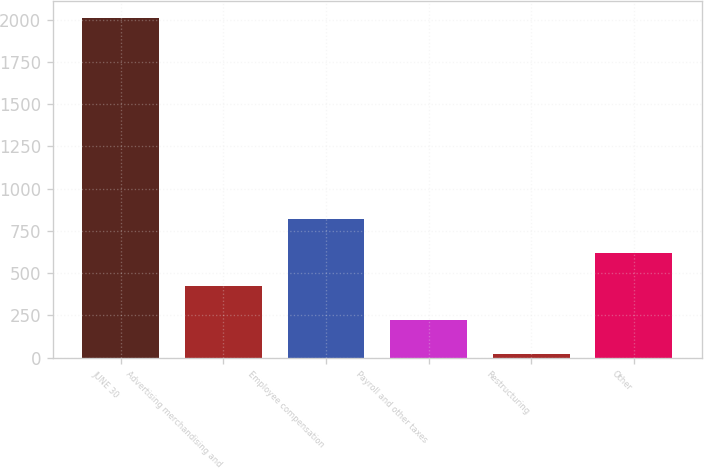Convert chart. <chart><loc_0><loc_0><loc_500><loc_500><bar_chart><fcel>JUNE 30<fcel>Advertising merchandising and<fcel>Employee compensation<fcel>Payroll and other taxes<fcel>Restructuring<fcel>Other<nl><fcel>2013<fcel>421.16<fcel>819.12<fcel>222.18<fcel>23.2<fcel>620.14<nl></chart> 